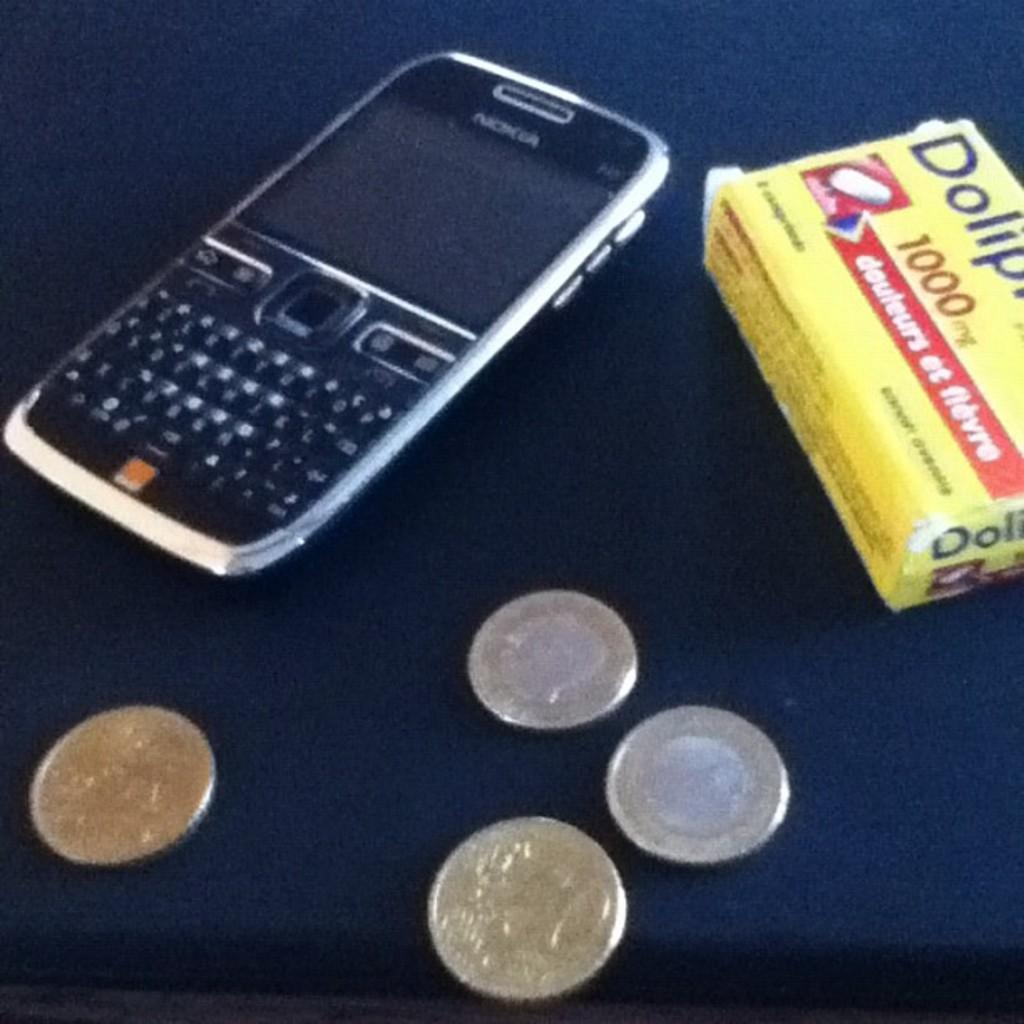<image>
Render a clear and concise summary of the photo. A cell phone, several coins, and a box of 1000mg pills sit on a table. 